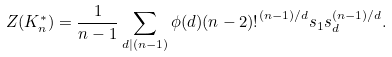Convert formula to latex. <formula><loc_0><loc_0><loc_500><loc_500>Z ( K _ { n } ^ { * } ) = \frac { 1 } { n - 1 } \sum _ { d | ( n - 1 ) } \phi ( d ) { ( n - 2 ) ! } ^ { ( n - 1 ) / d } s _ { 1 } s _ { d } ^ { ( n - 1 ) / d } .</formula> 